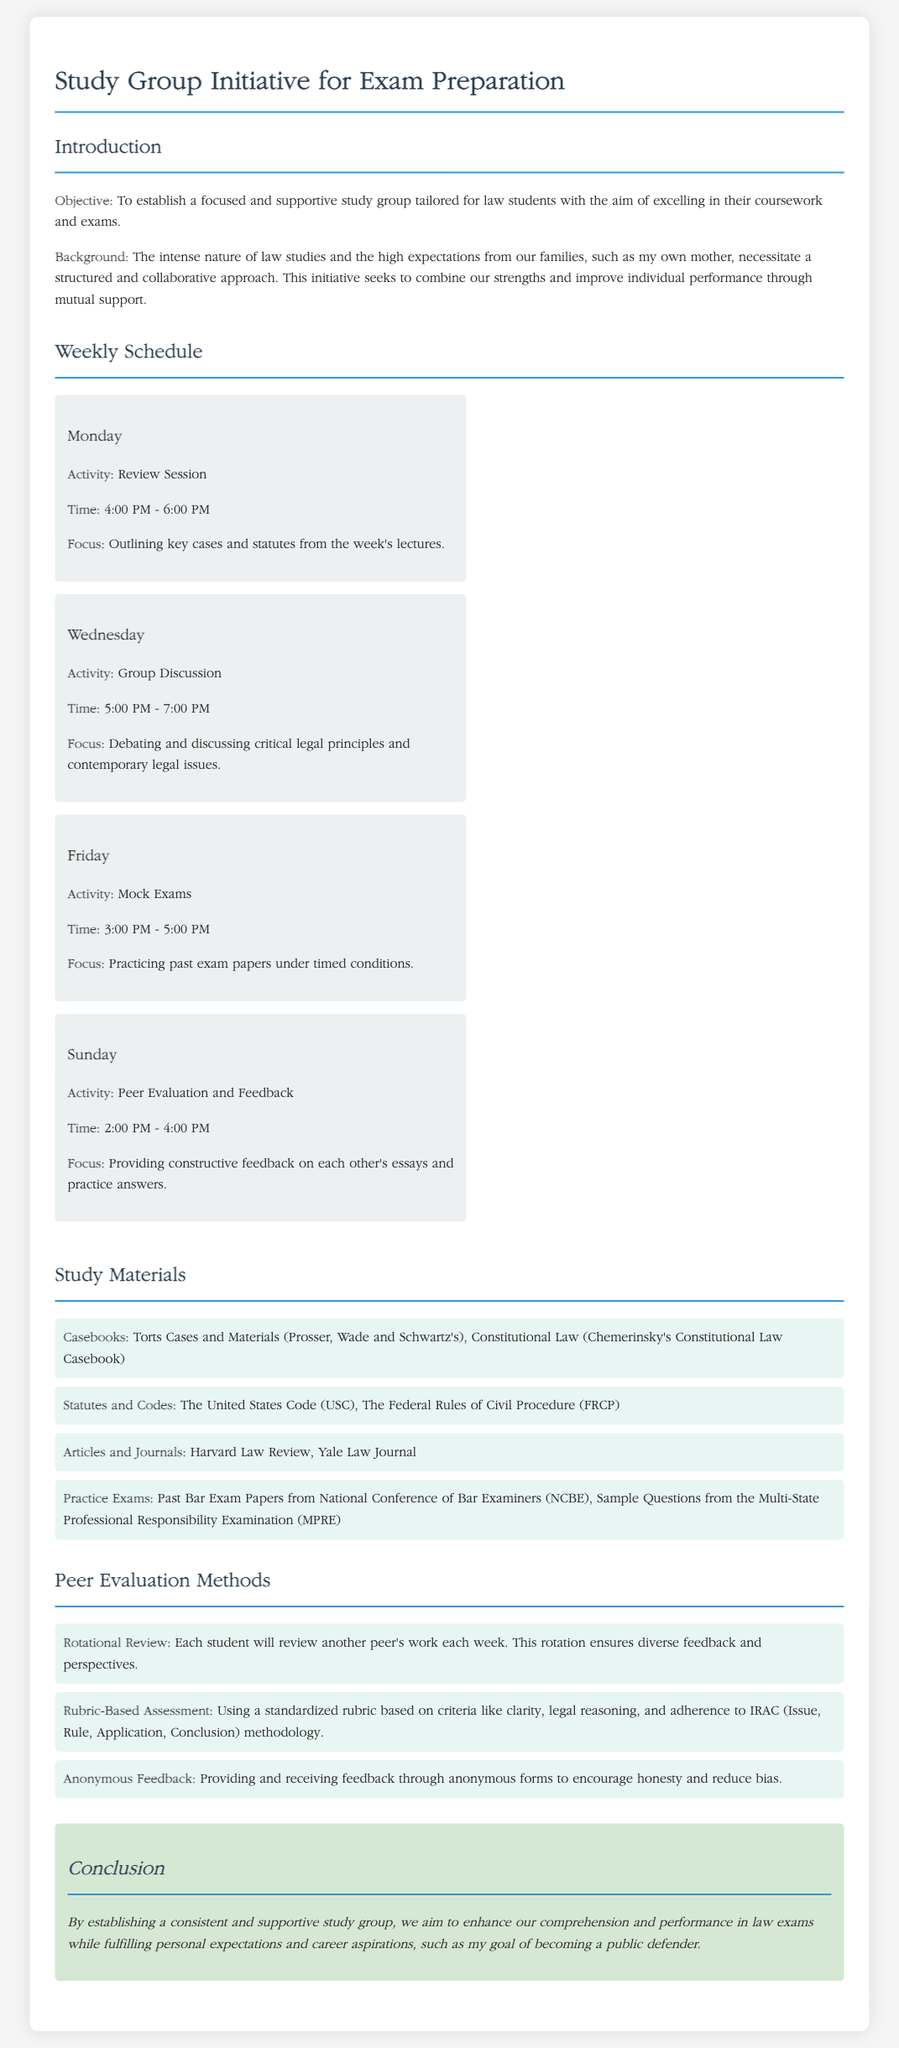What is the objective of the study group initiative? The objective is to establish a focused and supportive study group tailored for law students.
Answer: To establish a focused and supportive study group tailored for law students What day is the peer evaluation and feedback session scheduled? This is mentioned in the weekly schedule section.
Answer: Sunday How long is the review session on Monday? The duration of the session is indicated in the scheduled activities.
Answer: 2 hours What is one of the study materials listed? The materials section includes specific titles useful for law study.
Answer: Torts Cases and Materials What does the peer evaluation method 'Rotational Review' entail? This is described in the evaluation methods section.
Answer: Each student will review another peer's work each week What time does the group discussion take place on Wednesday? The schedule provides specific timings for each activity.
Answer: 5:00 PM - 7:00 PM What is the focus of the mock exams on Friday? This is outlined in the description for the Friday activity.
Answer: Practicing past exam papers under timed conditions What is the purpose of the study group according to the conclusion? The conclusion summarizes the primary intent and benefits of the study group.
Answer: Enhance our comprehension and performance in law exams 